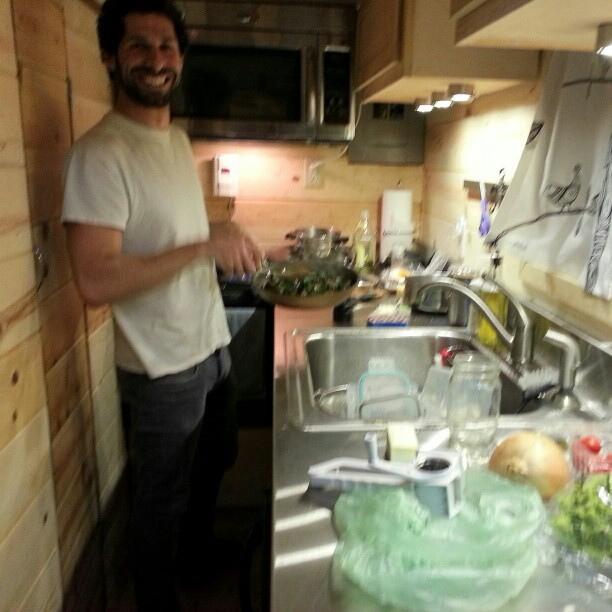Will this be for breakfast?
Short answer required. No. Does this man enjoy tiny spaces?
Write a very short answer. Yes. What is this man doing?
Answer briefly. Cooking. 